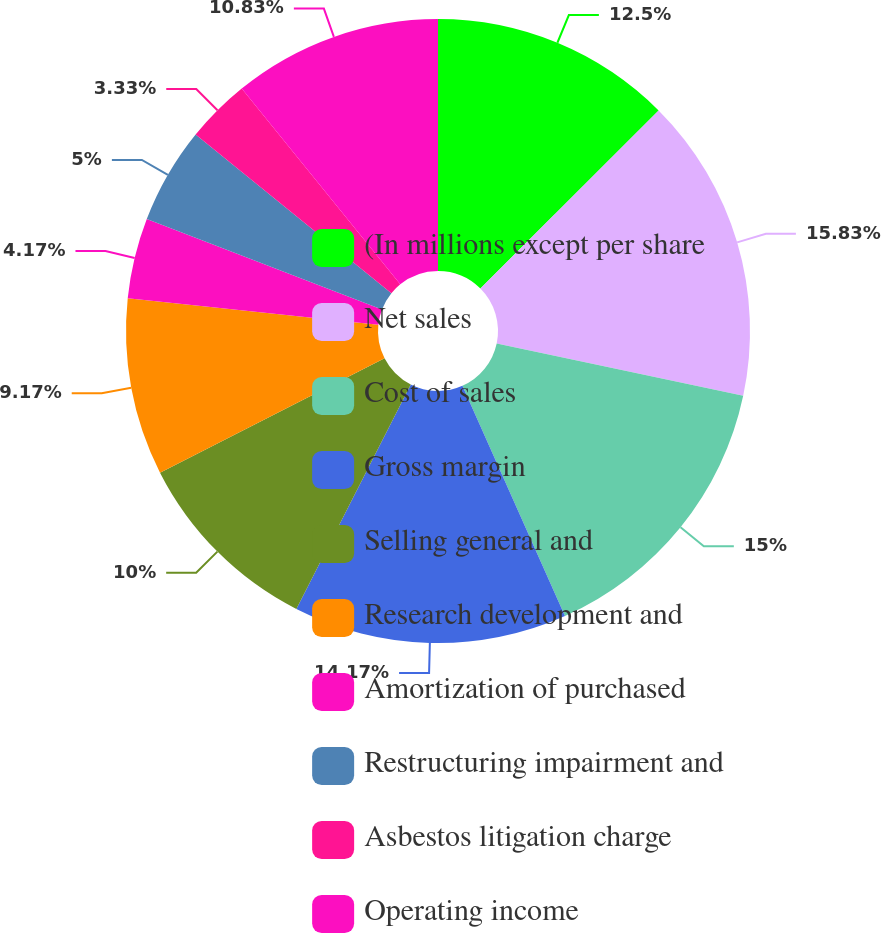<chart> <loc_0><loc_0><loc_500><loc_500><pie_chart><fcel>(In millions except per share<fcel>Net sales<fcel>Cost of sales<fcel>Gross margin<fcel>Selling general and<fcel>Research development and<fcel>Amortization of purchased<fcel>Restructuring impairment and<fcel>Asbestos litigation charge<fcel>Operating income<nl><fcel>12.5%<fcel>15.83%<fcel>15.0%<fcel>14.17%<fcel>10.0%<fcel>9.17%<fcel>4.17%<fcel>5.0%<fcel>3.33%<fcel>10.83%<nl></chart> 